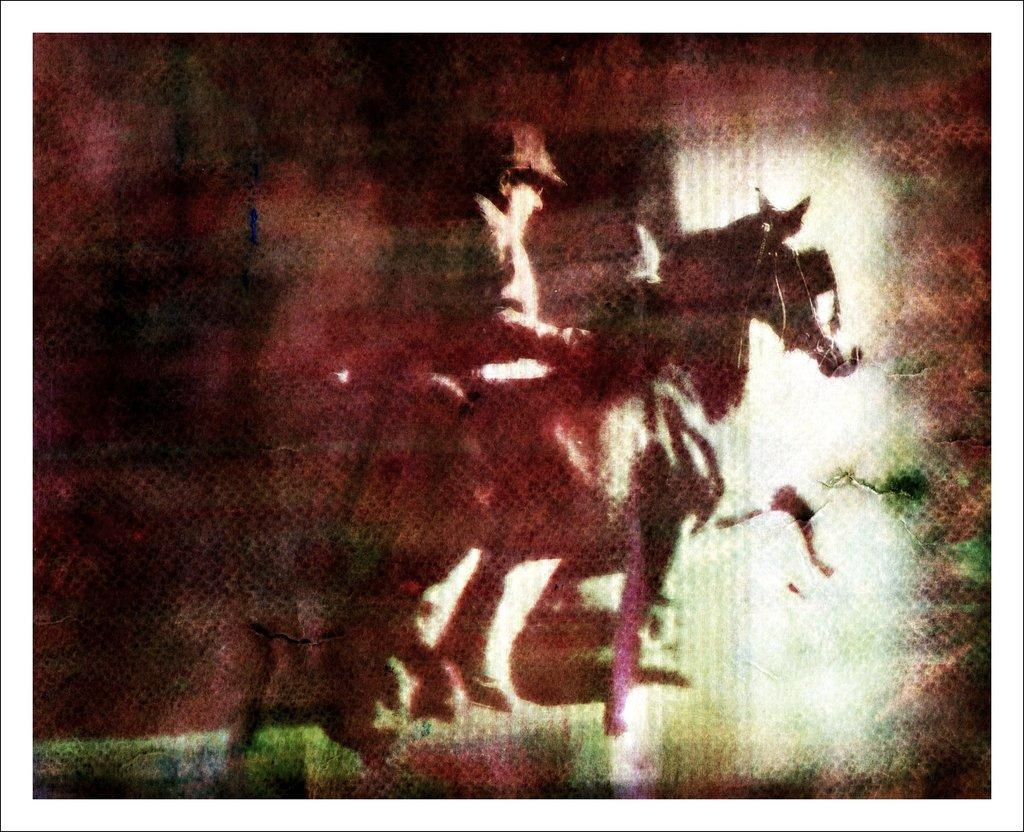Who or what is the main subject in the image? There is a person and a horse in the image. Can you describe the background of the image? The background of the image includes brown, black, and white colors. What type of volcano can be seen erupting in the background of the image? There is no volcano present in the image; the background consists of brown, black, and white colors. 